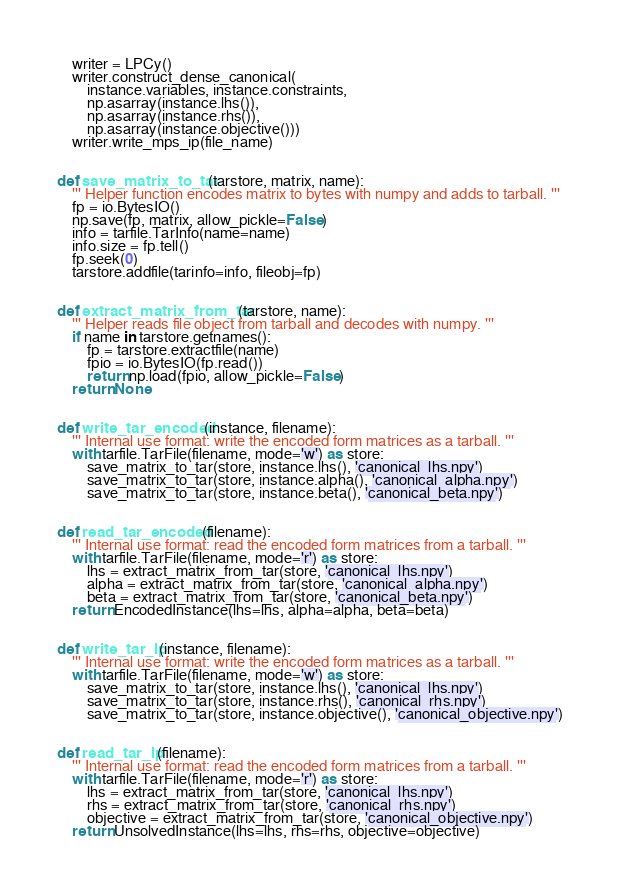<code> <loc_0><loc_0><loc_500><loc_500><_Python_>    writer = LPCy()
    writer.construct_dense_canonical(
        instance.variables, instance.constraints,
        np.asarray(instance.lhs()),
        np.asarray(instance.rhs()),
        np.asarray(instance.objective()))
    writer.write_mps_ip(file_name)


def save_matrix_to_tar(tarstore, matrix, name):
    ''' Helper function encodes matrix to bytes with numpy and adds to tarball. '''
    fp = io.BytesIO()
    np.save(fp, matrix, allow_pickle=False)
    info = tarfile.TarInfo(name=name)
    info.size = fp.tell()
    fp.seek(0)
    tarstore.addfile(tarinfo=info, fileobj=fp)


def extract_matrix_from_tar(tarstore, name):
    ''' Helper reads file object from tarball and decodes with numpy. '''
    if name in tarstore.getnames():
        fp = tarstore.extractfile(name)
        fpio = io.BytesIO(fp.read())
        return np.load(fpio, allow_pickle=False)
    return None


def write_tar_encoded(instance, filename):
    ''' Internal use format: write the encoded form matrices as a tarball. '''
    with tarfile.TarFile(filename, mode='w') as store:
        save_matrix_to_tar(store, instance.lhs(), 'canonical_lhs.npy')
        save_matrix_to_tar(store, instance.alpha(), 'canonical_alpha.npy')
        save_matrix_to_tar(store, instance.beta(), 'canonical_beta.npy')


def read_tar_encoded(filename):
    ''' Internal use format: read the encoded form matrices from a tarball. '''
    with tarfile.TarFile(filename, mode='r') as store:
        lhs = extract_matrix_from_tar(store, 'canonical_lhs.npy')
        alpha = extract_matrix_from_tar(store, 'canonical_alpha.npy')
        beta = extract_matrix_from_tar(store, 'canonical_beta.npy')
    return EncodedInstance(lhs=lhs, alpha=alpha, beta=beta)


def write_tar_lp(instance, filename):
    ''' Internal use format: write the encoded form matrices as a tarball. '''
    with tarfile.TarFile(filename, mode='w') as store:
        save_matrix_to_tar(store, instance.lhs(), 'canonical_lhs.npy')
        save_matrix_to_tar(store, instance.rhs(), 'canonical_rhs.npy')
        save_matrix_to_tar(store, instance.objective(), 'canonical_objective.npy')


def read_tar_lp(filename):
    ''' Internal use format: read the encoded form matrices from a tarball. '''
    with tarfile.TarFile(filename, mode='r') as store:
        lhs = extract_matrix_from_tar(store, 'canonical_lhs.npy')
        rhs = extract_matrix_from_tar(store, 'canonical_rhs.npy')
        objective = extract_matrix_from_tar(store, 'canonical_objective.npy')
    return UnsolvedInstance(lhs=lhs, rhs=rhs, objective=objective)
</code> 